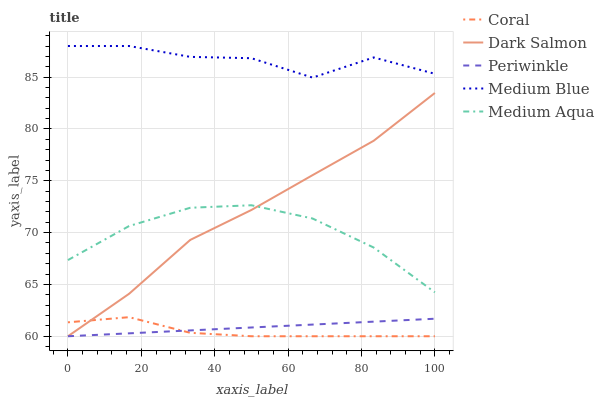Does Coral have the minimum area under the curve?
Answer yes or no. Yes. Does Medium Blue have the maximum area under the curve?
Answer yes or no. Yes. Does Medium Blue have the minimum area under the curve?
Answer yes or no. No. Does Coral have the maximum area under the curve?
Answer yes or no. No. Is Periwinkle the smoothest?
Answer yes or no. Yes. Is Medium Blue the roughest?
Answer yes or no. Yes. Is Coral the smoothest?
Answer yes or no. No. Is Coral the roughest?
Answer yes or no. No. Does Medium Blue have the lowest value?
Answer yes or no. No. Does Medium Blue have the highest value?
Answer yes or no. Yes. Does Coral have the highest value?
Answer yes or no. No. Is Coral less than Medium Aqua?
Answer yes or no. Yes. Is Medium Blue greater than Dark Salmon?
Answer yes or no. Yes. Does Periwinkle intersect Dark Salmon?
Answer yes or no. Yes. Is Periwinkle less than Dark Salmon?
Answer yes or no. No. Is Periwinkle greater than Dark Salmon?
Answer yes or no. No. Does Coral intersect Medium Aqua?
Answer yes or no. No. 